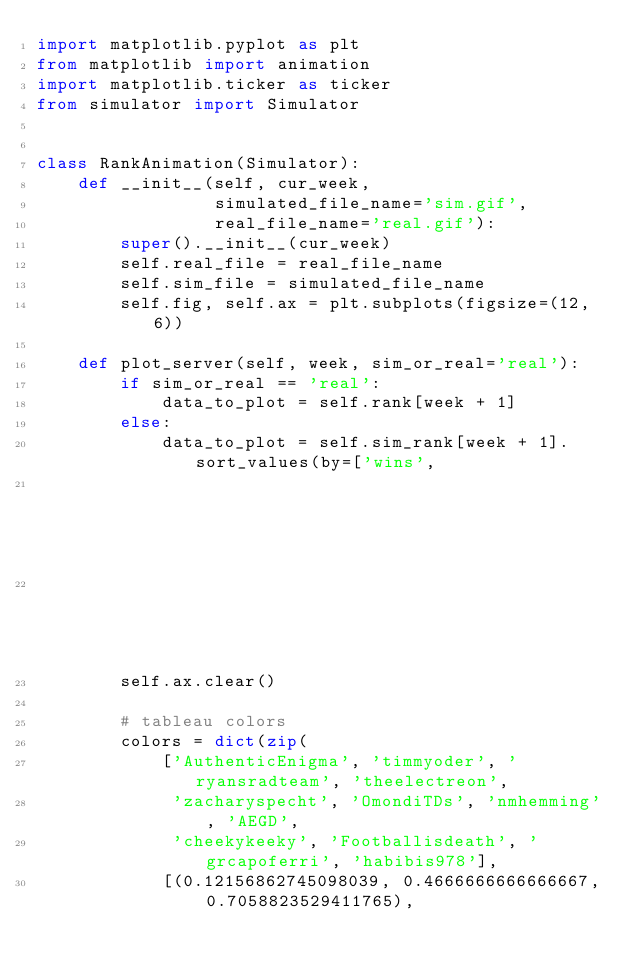<code> <loc_0><loc_0><loc_500><loc_500><_Python_>import matplotlib.pyplot as plt
from matplotlib import animation
import matplotlib.ticker as ticker
from simulator import Simulator


class RankAnimation(Simulator):
    def __init__(self, cur_week,
                 simulated_file_name='sim.gif',
                 real_file_name='real.gif'):
        super().__init__(cur_week)
        self.real_file = real_file_name
        self.sim_file = simulated_file_name
        self.fig, self.ax = plt.subplots(figsize=(12, 6))

    def plot_server(self, week, sim_or_real='real'):
        if sim_or_real == 'real':
            data_to_plot = self.rank[week + 1]
        else:
            data_to_plot = self.sim_rank[week + 1].sort_values(by=['wins',
                                                                   'total_score'],
                                                               ascending=False)
        self.ax.clear()

        # tableau colors
        colors = dict(zip(
            ['AuthenticEnigma', 'timmyoder', 'ryansradteam', 'theelectreon',
             'zacharyspecht', 'OmondiTDs', 'nmhemming', 'AEGD',
             'cheekykeeky', 'Footballisdeath', 'grcapoferri', 'habibis978'],
            [(0.12156862745098039, 0.4666666666666667, 0.7058823529411765),</code> 